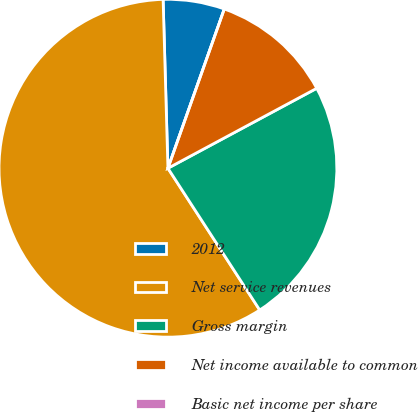Convert chart to OTSL. <chart><loc_0><loc_0><loc_500><loc_500><pie_chart><fcel>2012<fcel>Net service revenues<fcel>Gross margin<fcel>Net income available to common<fcel>Basic net income per share<nl><fcel>5.87%<fcel>58.69%<fcel>23.7%<fcel>11.74%<fcel>0.0%<nl></chart> 